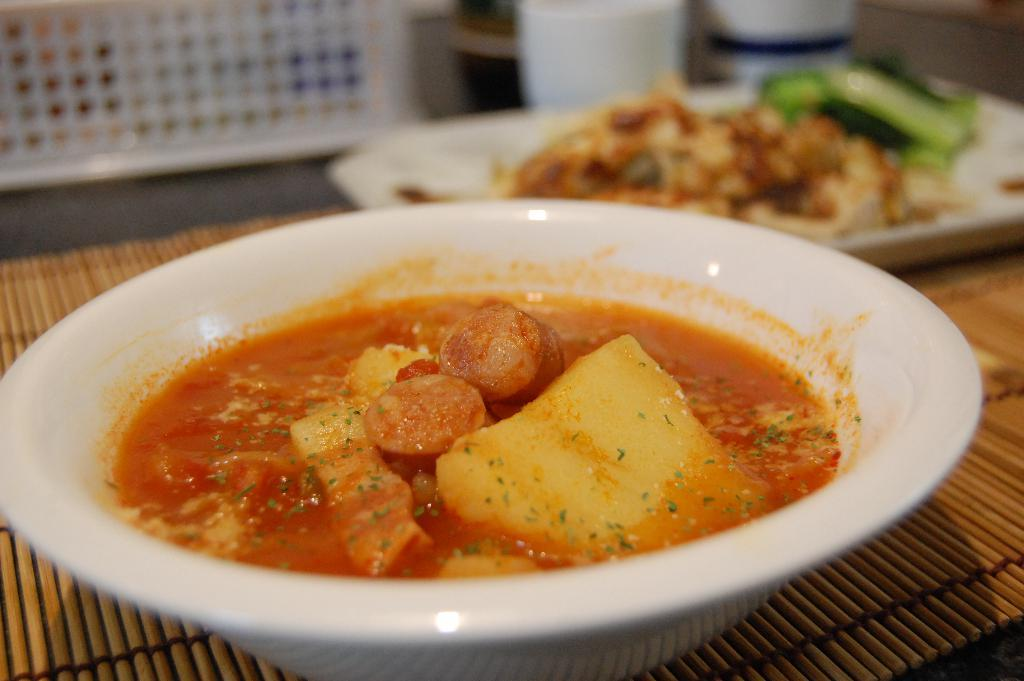What types of food items can be seen in the image? There are food items on a plate and in a bowl in the image. Where are the plate and bowl located? The plate and bowl are on a dining place-mat. What can be seen in the background of the image? There are objects visible in the background of the image. How does the circle of food items increase in size in the image? There is no circle of food items present in the image. 